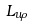Convert formula to latex. <formula><loc_0><loc_0><loc_500><loc_500>\ L _ { u \rho }</formula> 